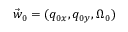<formula> <loc_0><loc_0><loc_500><loc_500>\vec { w } _ { 0 } = ( q _ { 0 x } , q _ { 0 y } , \Omega _ { 0 } )</formula> 